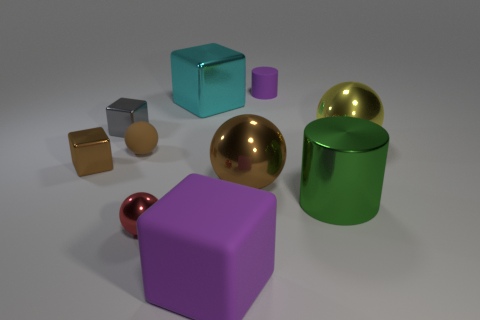Is the size of the rubber object that is behind the yellow shiny thing the same as the purple thing in front of the yellow shiny sphere?
Provide a short and direct response. No. What is the material of the small ball behind the brown metal thing that is in front of the brown metallic block?
Provide a succinct answer. Rubber. How many things are metal things that are to the left of the purple cylinder or tiny gray shiny cubes?
Your answer should be very brief. 5. Are there an equal number of red spheres behind the tiny red metal ball and big metal cylinders that are behind the large shiny cylinder?
Provide a short and direct response. Yes. What is the material of the big ball left of the small purple object on the left side of the ball that is right of the tiny cylinder?
Offer a very short reply. Metal. There is a shiny ball that is both behind the large cylinder and to the left of the small cylinder; what size is it?
Offer a very short reply. Large. Does the tiny purple object have the same shape as the large purple object?
Offer a terse response. No. There is a large purple thing that is made of the same material as the tiny brown ball; what shape is it?
Provide a succinct answer. Cube. What number of large things are metal cubes or cyan things?
Provide a succinct answer. 1. Are there any tiny metallic spheres that are left of the brown thing that is to the left of the gray block?
Provide a succinct answer. No. 